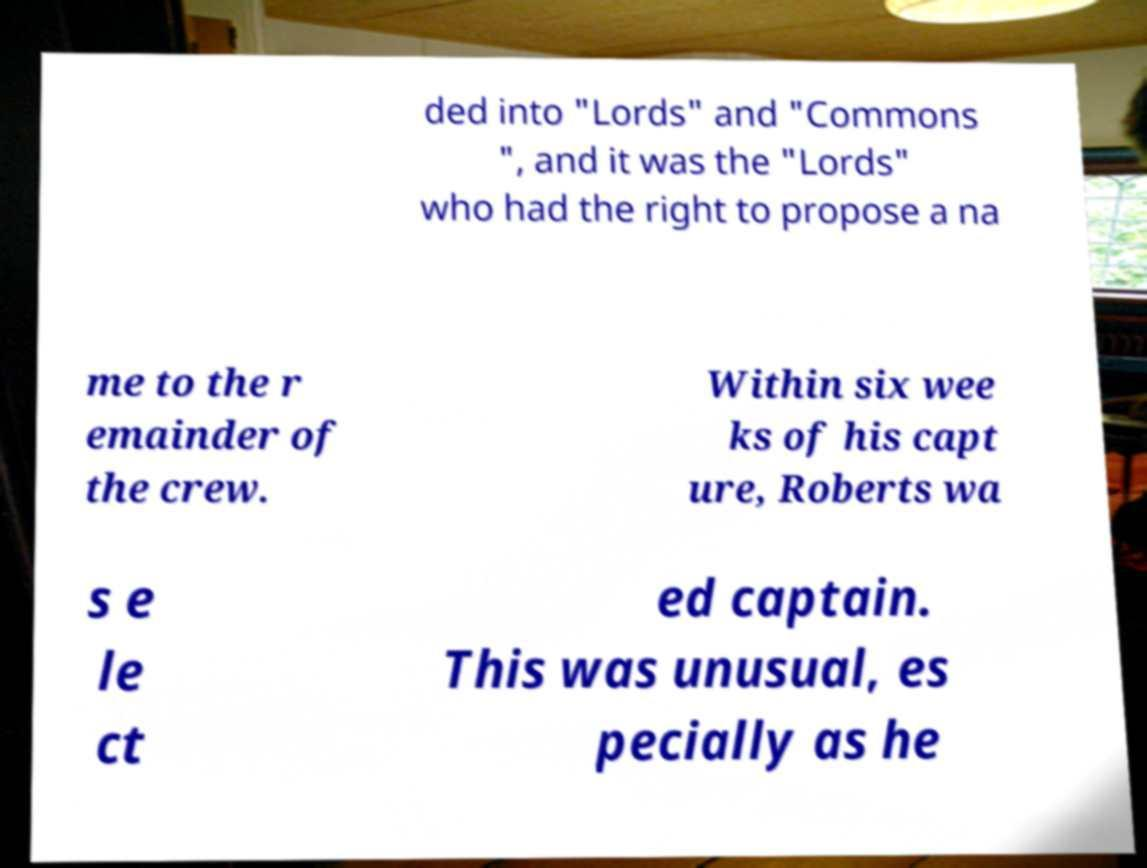Can you read and provide the text displayed in the image?This photo seems to have some interesting text. Can you extract and type it out for me? ded into "Lords" and "Commons ", and it was the "Lords" who had the right to propose a na me to the r emainder of the crew. Within six wee ks of his capt ure, Roberts wa s e le ct ed captain. This was unusual, es pecially as he 